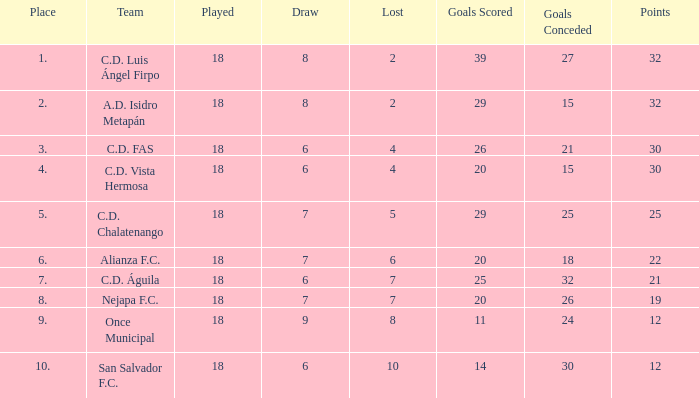Which team has allowed less than 25 goals and is positioned in the top 3? A.D. Isidro Metapán. 